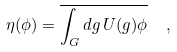Convert formula to latex. <formula><loc_0><loc_0><loc_500><loc_500>\eta ( \phi ) = \overline { \int _ { G } d g \, U ( g ) \phi } \ \ ,</formula> 